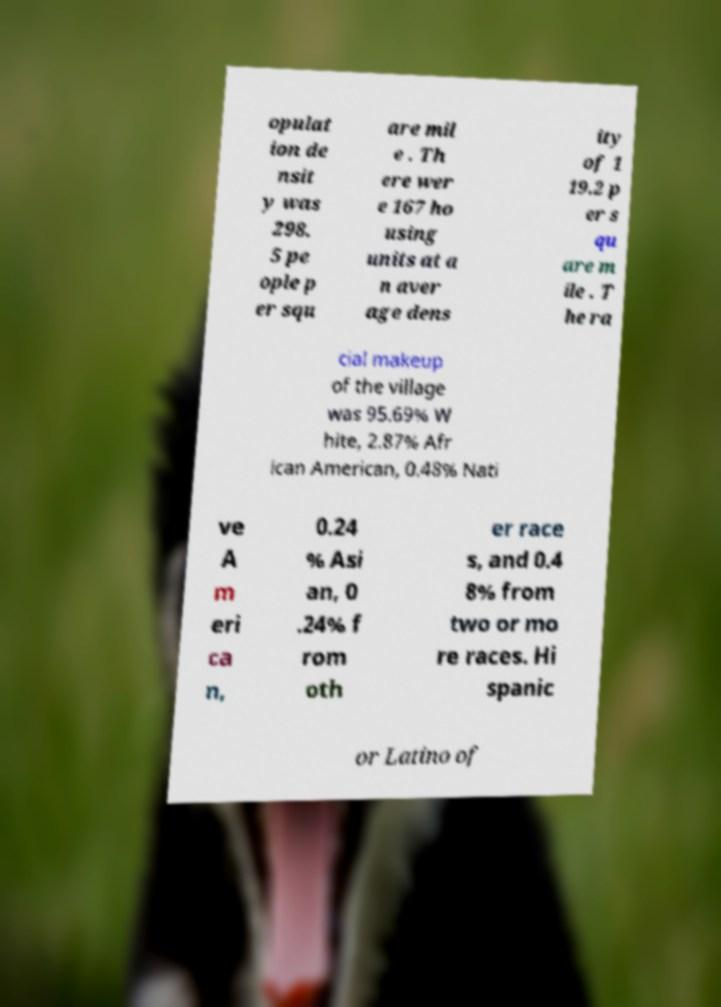Could you extract and type out the text from this image? opulat ion de nsit y was 298. 5 pe ople p er squ are mil e . Th ere wer e 167 ho using units at a n aver age dens ity of 1 19.2 p er s qu are m ile . T he ra cial makeup of the village was 95.69% W hite, 2.87% Afr ican American, 0.48% Nati ve A m eri ca n, 0.24 % Asi an, 0 .24% f rom oth er race s, and 0.4 8% from two or mo re races. Hi spanic or Latino of 